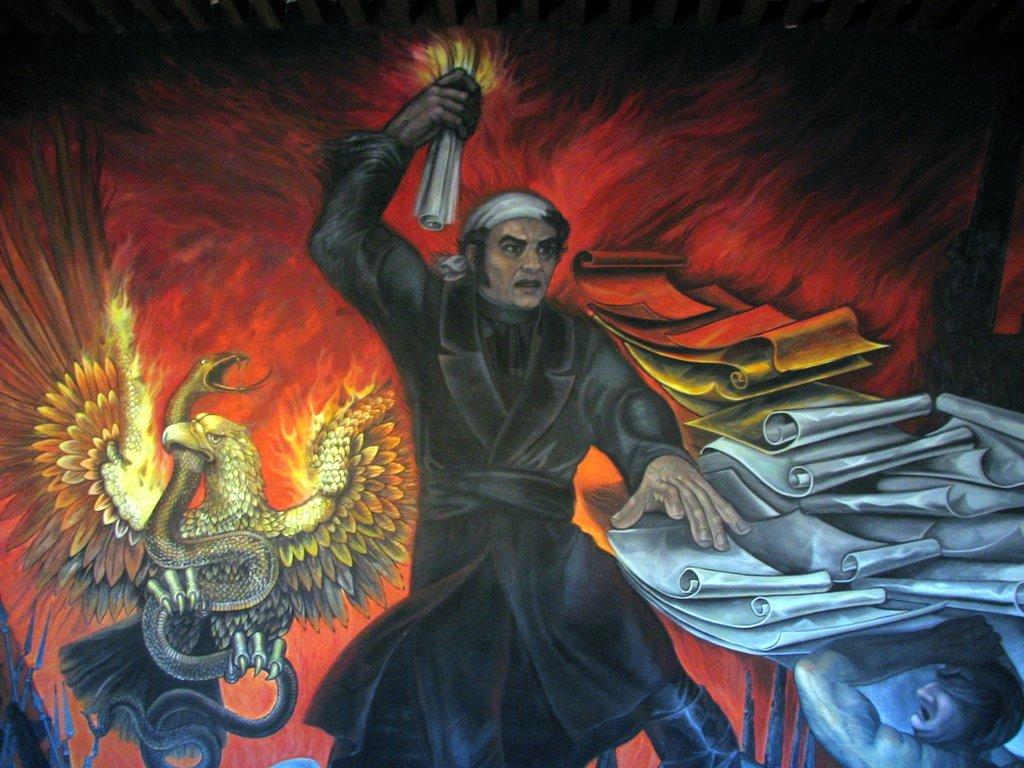What type of artwork is depicted in the image? The image is a painting. How many people are in the painting? There are two men in the painting. What animals are present in the painting? There is an eagle and a snake in the painting. What objects can be seen in the painting? There are papers in the painting. How long does it take for the shade to change in the painting? There is no mention of a shade or any changing elements in the painting, so it is not possible to answer this question. 